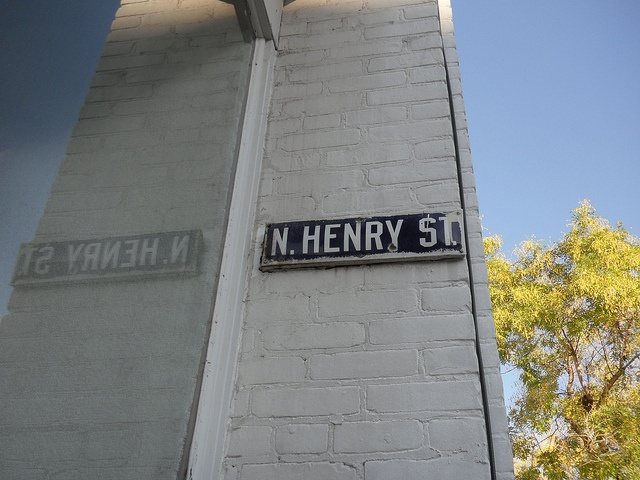Describe the objects in this image and their specific colors. I can see various objects in this image with different colors. 